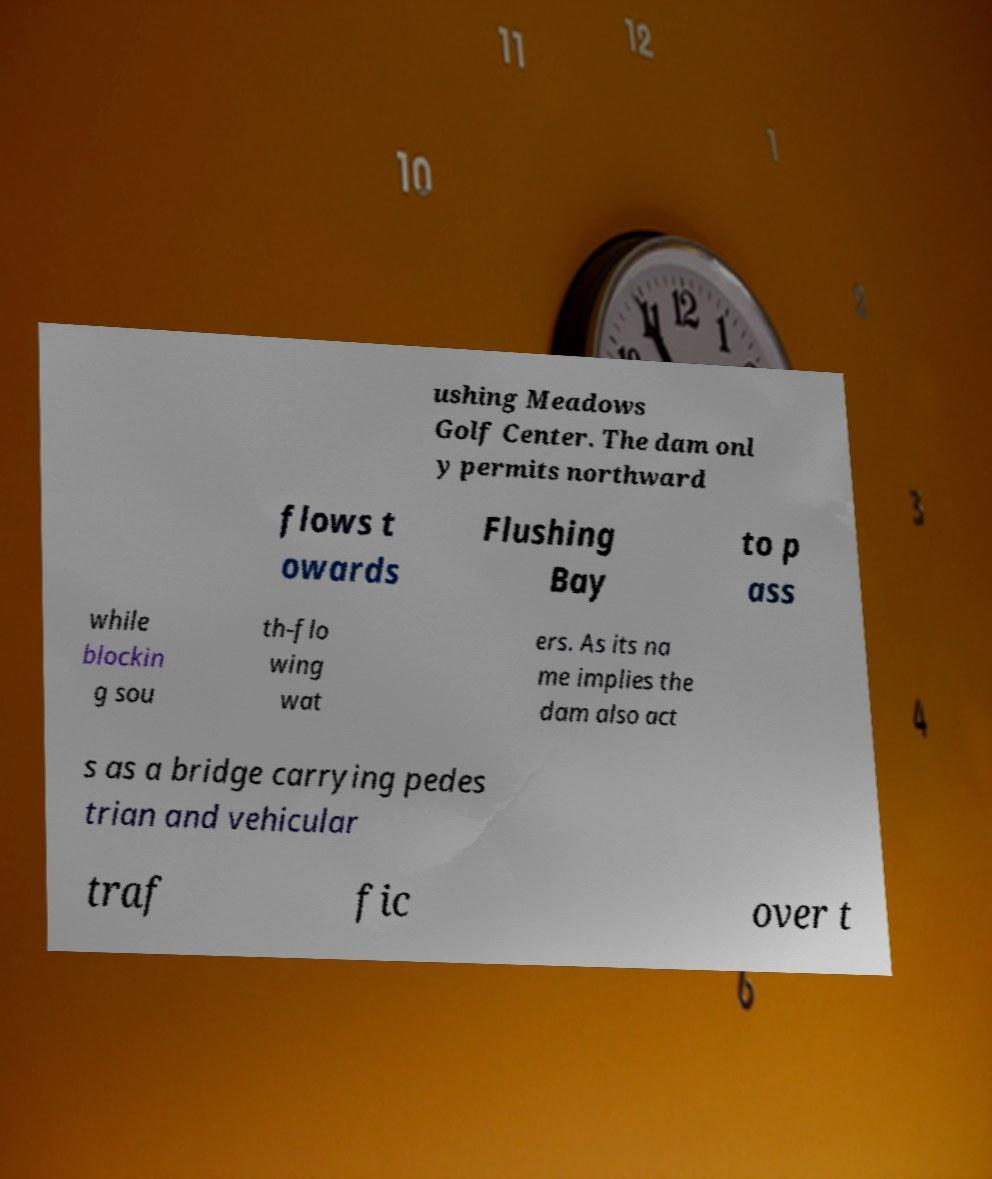Can you accurately transcribe the text from the provided image for me? ushing Meadows Golf Center. The dam onl y permits northward flows t owards Flushing Bay to p ass while blockin g sou th-flo wing wat ers. As its na me implies the dam also act s as a bridge carrying pedes trian and vehicular traf fic over t 